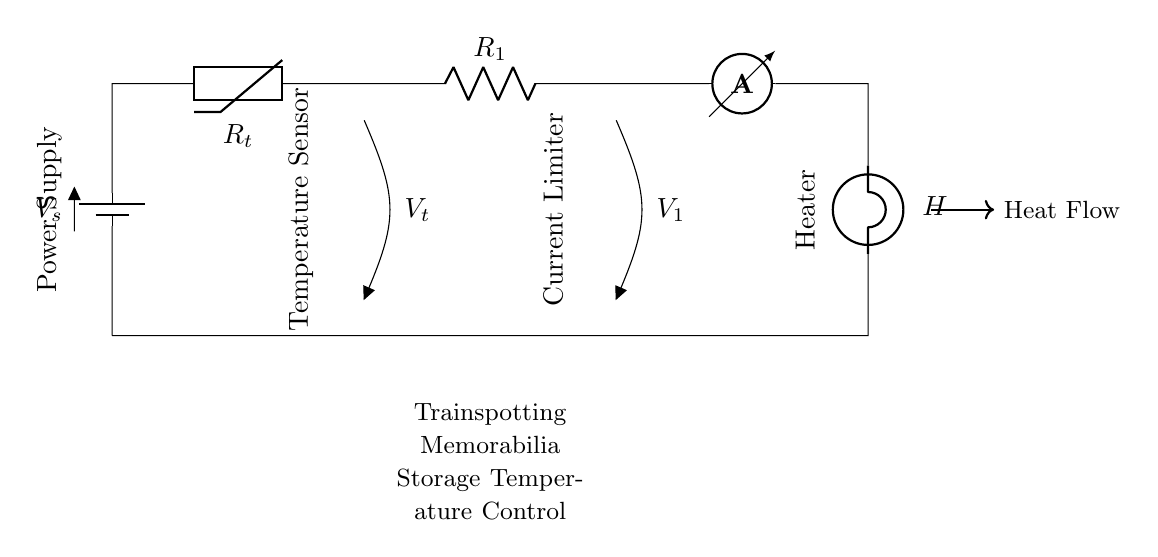What is the main function of the thermistor in this circuit? The thermistor acts as a temperature sensor, changing its resistance with temperature changes to maintain optimal conditions.
Answer: Temperature sensor What component limits the current in the circuit? The circuit has a resistor designated as R1, which acts as the current limiter to prevent excess current flow affecting the heater.
Answer: R1 What type of bulb is used in this circuit? The circuit uses a heater bulb indicated by the label H, which is specifically designed to produce heat for maintaining temperature.
Answer: Heater What is the power supply voltage symbol in this circuit? The voltage supply is represented by the symbol V_s, indicating the battery's voltage output to the entire circuit.
Answer: V_s What happens to the circuit if the temperature rises? If the temperature rises, the thermistor's resistance decreases, which increases current through the system, causing the heater to activate and regulate the temperature back down.
Answer: Heater activates How many voltage points are shown in the circuit? There are two voltage points indicated: V_t across the thermistor and V_1 across the current limiter R1, providing key measurements along the circuit.
Answer: Two What role does the ammeter play in this circuit? The ammeter measures the current flowing through the circuit, ensuring that the heater operates within safe current levels to prevent overheating.
Answer: Current measurement 